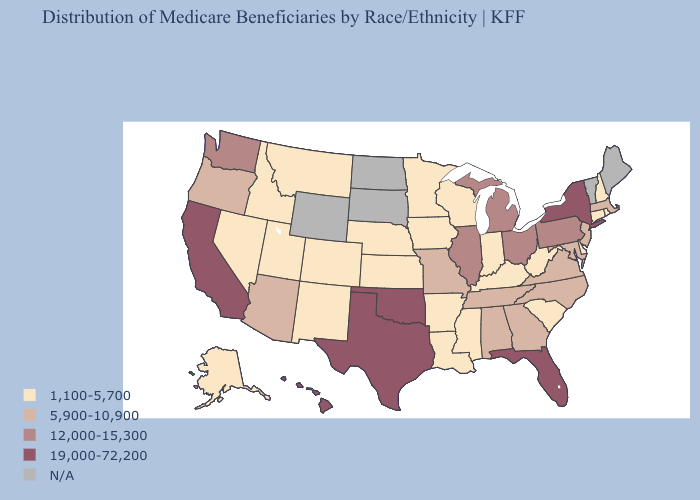Is the legend a continuous bar?
Be succinct. No. Among the states that border Indiana , does Kentucky have the highest value?
Give a very brief answer. No. Name the states that have a value in the range 1,100-5,700?
Give a very brief answer. Alaska, Arkansas, Colorado, Connecticut, Delaware, Idaho, Indiana, Iowa, Kansas, Kentucky, Louisiana, Minnesota, Mississippi, Montana, Nebraska, Nevada, New Hampshire, New Mexico, Rhode Island, South Carolina, Utah, West Virginia, Wisconsin. Which states hav the highest value in the Northeast?
Write a very short answer. New York. Does Hawaii have the highest value in the USA?
Give a very brief answer. Yes. What is the value of Wyoming?
Short answer required. N/A. Name the states that have a value in the range 19,000-72,200?
Give a very brief answer. California, Florida, Hawaii, New York, Oklahoma, Texas. Among the states that border Texas , which have the highest value?
Quick response, please. Oklahoma. Name the states that have a value in the range 19,000-72,200?
Be succinct. California, Florida, Hawaii, New York, Oklahoma, Texas. Does the first symbol in the legend represent the smallest category?
Quick response, please. Yes. Name the states that have a value in the range 1,100-5,700?
Concise answer only. Alaska, Arkansas, Colorado, Connecticut, Delaware, Idaho, Indiana, Iowa, Kansas, Kentucky, Louisiana, Minnesota, Mississippi, Montana, Nebraska, Nevada, New Hampshire, New Mexico, Rhode Island, South Carolina, Utah, West Virginia, Wisconsin. Which states hav the highest value in the MidWest?
Answer briefly. Illinois, Michigan, Ohio. Name the states that have a value in the range 5,900-10,900?
Concise answer only. Alabama, Arizona, Georgia, Maryland, Massachusetts, Missouri, New Jersey, North Carolina, Oregon, Tennessee, Virginia. What is the lowest value in states that border Washington?
Keep it brief. 1,100-5,700. What is the value of Connecticut?
Concise answer only. 1,100-5,700. 